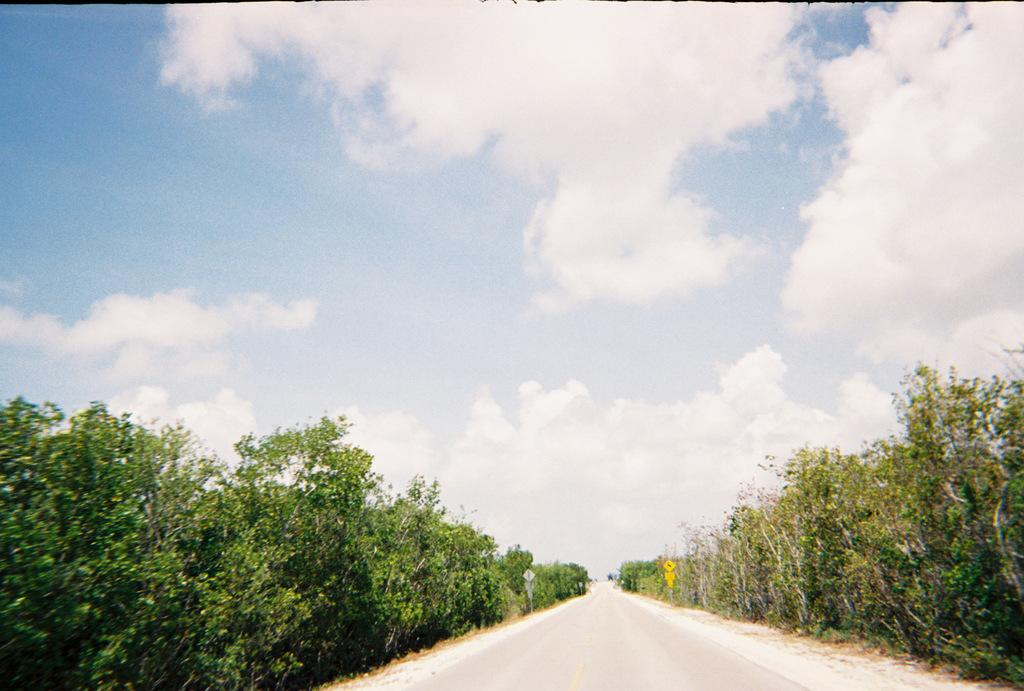What is the main feature of the image? There is a road in the image. Are there any other structures or objects visible along the road? Yes, there are two sign boards in the image. What type of vegetation can be seen in the image? There are many plants in the image. How would you describe the weather based on the sky in the image? The sky is blue and cloudy in the image, suggesting partly cloudy weather. What rule is being enforced by the airplane in the image? There is no airplane present in the image, so no rule enforcement can be observed. 